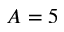Convert formula to latex. <formula><loc_0><loc_0><loc_500><loc_500>A = 5</formula> 